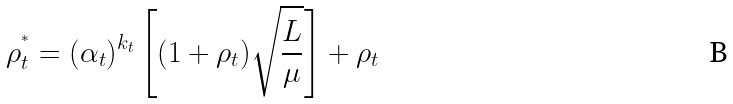Convert formula to latex. <formula><loc_0><loc_0><loc_500><loc_500>\rho _ { t } ^ { ^ { * } } = ( \alpha _ { t } ) ^ { k _ { t } } \left [ ( 1 + \rho _ { t } ) \sqrt { \frac { L } { \mu } } \right ] + \rho _ { t }</formula> 